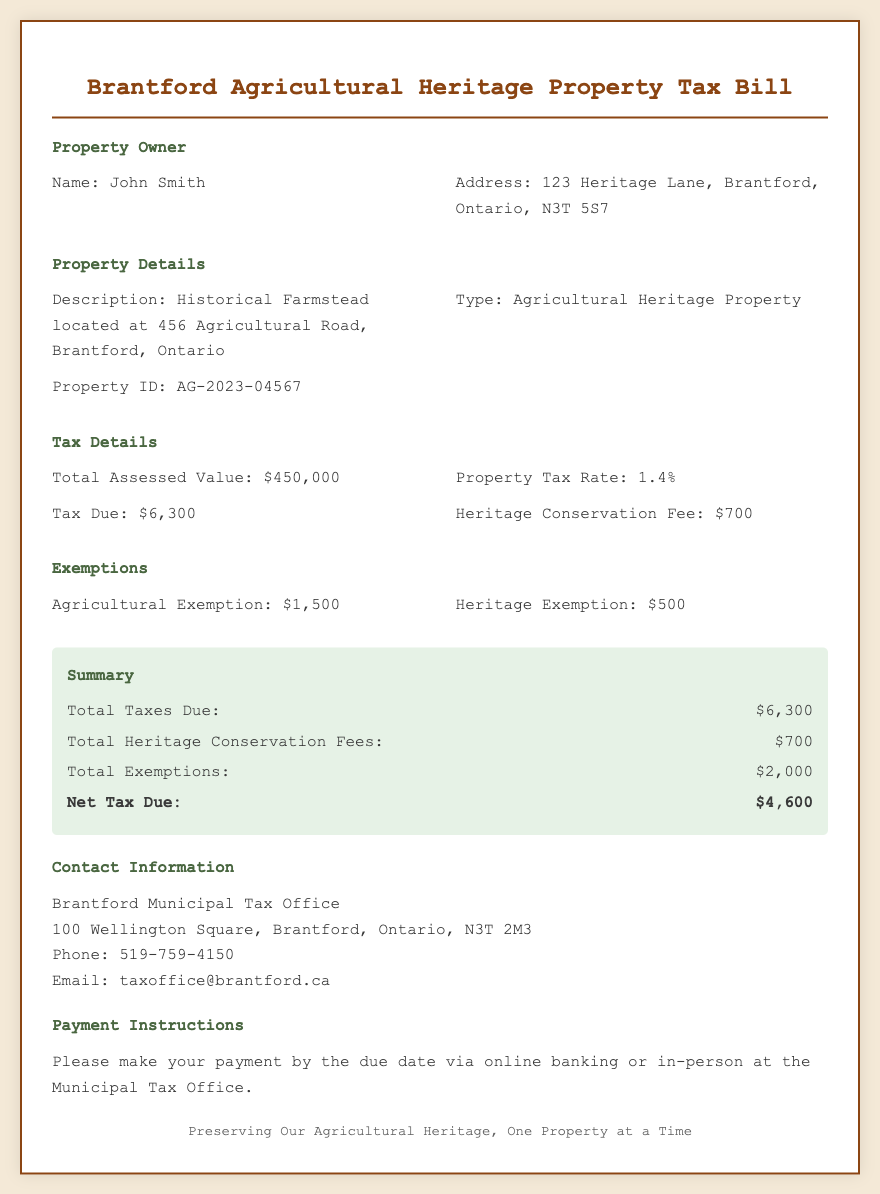What is the name of the property owner? The name of the property owner can be found in the Property Owner section, listed as John Smith.
Answer: John Smith What is the total assessed value of the property? The total assessed value is mentioned in the Tax Details section as $450,000.
Answer: $450,000 What is the Property Tax Rate? The Property Tax Rate is specified in the Tax Details section as 1.4%.
Answer: 1.4% What is the amount of the Heritage Conservation Fee? The Heritage Conservation Fee is provided in the Tax Details section as $700.
Answer: $700 What is the total amount of exemptions? The total amount of exemptions is detailed in the Exemptions section, which sums up to $2,000.
Answer: $2,000 What is the Net Tax Due after exemptions? The Net Tax Due can be calculated by subtracting the total exemptions from the total taxes due, resulting in $4,600.
Answer: $4,600 What is the address of the Brantford Municipal Tax Office? The address is given in the Contact Information section as 100 Wellington Square, Brantford, Ontario, N3T 2M3.
Answer: 100 Wellington Square, Brantford, Ontario, N3T 2M3 What payment methods are accepted? Payment methods are noted in the Payment Instructions section as online banking or in-person at the Municipal Tax Office.
Answer: Online banking or in-person What is the significance of the property type mentioned in the document? The property type is categorized as an Agricultural Heritage Property, which indicates its historical significance and eligibility for specific fees and exemptions.
Answer: Agricultural Heritage Property 